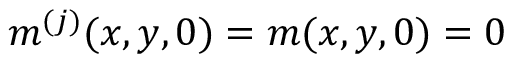<formula> <loc_0><loc_0><loc_500><loc_500>m ^ { ( j ) } ( x , y , 0 ) = m ( x , y , 0 ) = 0</formula> 